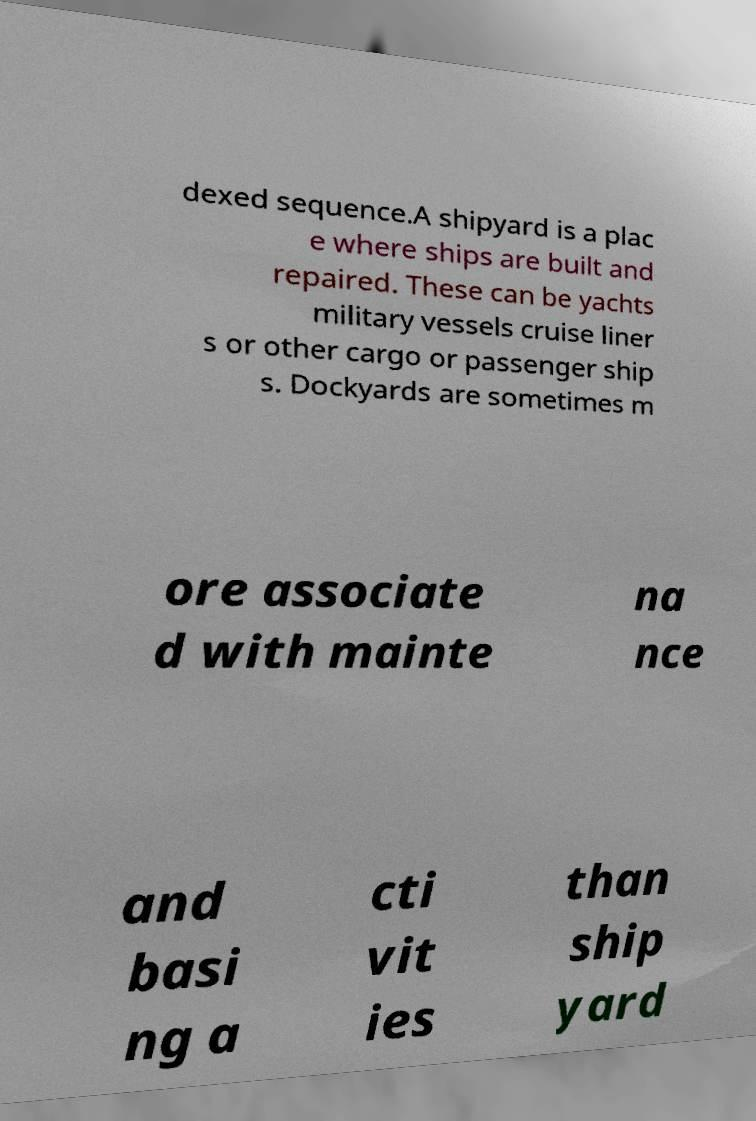What messages or text are displayed in this image? I need them in a readable, typed format. dexed sequence.A shipyard is a plac e where ships are built and repaired. These can be yachts military vessels cruise liner s or other cargo or passenger ship s. Dockyards are sometimes m ore associate d with mainte na nce and basi ng a cti vit ies than ship yard 